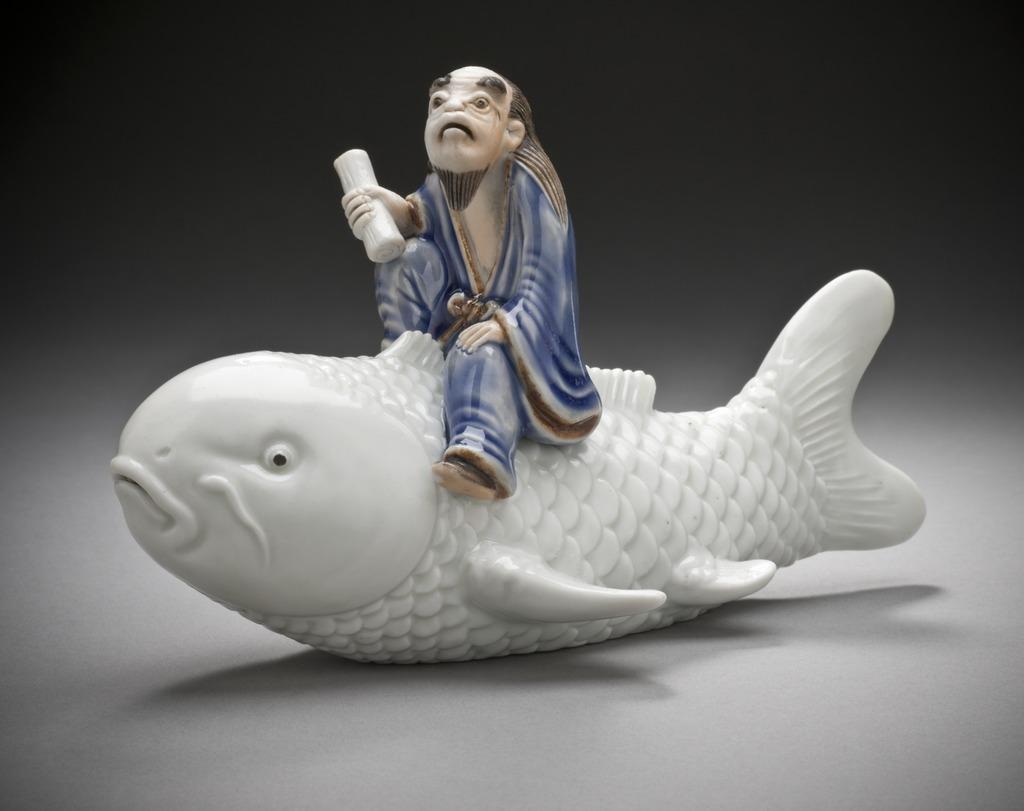How would you summarize this image in a sentence or two? As we can see in the image in the front there is a man statue sitting on fish statue. The background is dark. 